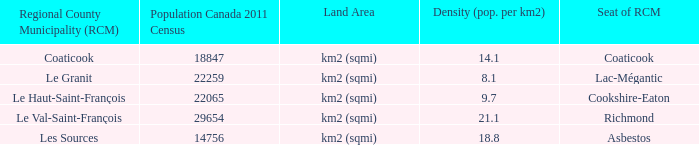What is the seat of the county that has a density of 14.1? Coaticook. 